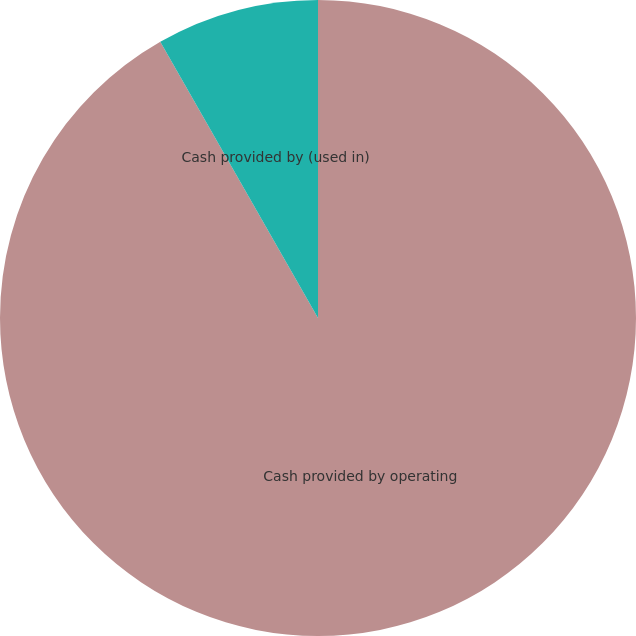Convert chart to OTSL. <chart><loc_0><loc_0><loc_500><loc_500><pie_chart><fcel>Cash provided by operating<fcel>Cash provided by (used in)<nl><fcel>91.74%<fcel>8.26%<nl></chart> 